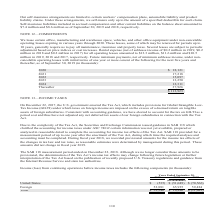According to Cubic's financial document, The Securities and Exchange Commission issued guidance in SAB 118 provided what form of clarification? the accounting for income taxes under ASC 740 if certain information was not yet available, prepared or analyzed in reasonable detail to complete the accounting for income tax effects of the Tax Act. The document states: "ission issued guidance in SAB 118 which clarified the accounting for income taxes under ASC 740 if certain information was not yet available, prepared..." Also, How may the determination of the Tax Act's income tax effects change? following future legislation or further interpretation of the Tax Act based on the publication of recently proposed U.S. Treasury regulations and guidance from the Internal Revenue Service and state tax authorities. The document states: "on of the Tax Act’s income tax effects may change following future legislation or further interpretation of the Tax Act based on the publication of re..." Also, What are the components recorded under income (loss) from continuing operations before income taxes? The document shows two values: United States and Foreign. From the document: "United States $ (535) $ (51,049) $ (70,566) Foreign 52,881 65,935 59,484 United States $ (535) $ (51,049) $ (70,566) Foreign 52,881 65,935 59,484..." Additionally, In which year was the amount under Foreign the smallest? According to the financial document, 2019. The relevant text states: "Years Ended September 30, 2019 2018 2017..." Also, can you calculate: What is the change in the amount under Foreign in 2019 from 2018? Based on the calculation: 52,881-65,935, the result is -13054 (in thousands). This is based on the information: "ates $ (535) $ (51,049) $ (70,566) Foreign 52,881 65,935 59,484 ited States $ (535) $ (51,049) $ (70,566) Foreign 52,881 65,935 59,484..." The key data points involved are: 52,881, 65,935. Also, can you calculate: What is the percentage change in the amount under Foreign in 2019 from 2018? To answer this question, I need to perform calculations using the financial data. The calculation is: (52,881-65,935)/65,935, which equals -19.8 (percentage). This is based on the information: "ates $ (535) $ (51,049) $ (70,566) Foreign 52,881 65,935 59,484 ited States $ (535) $ (51,049) $ (70,566) Foreign 52,881 65,935 59,484..." The key data points involved are: 52,881, 65,935. 